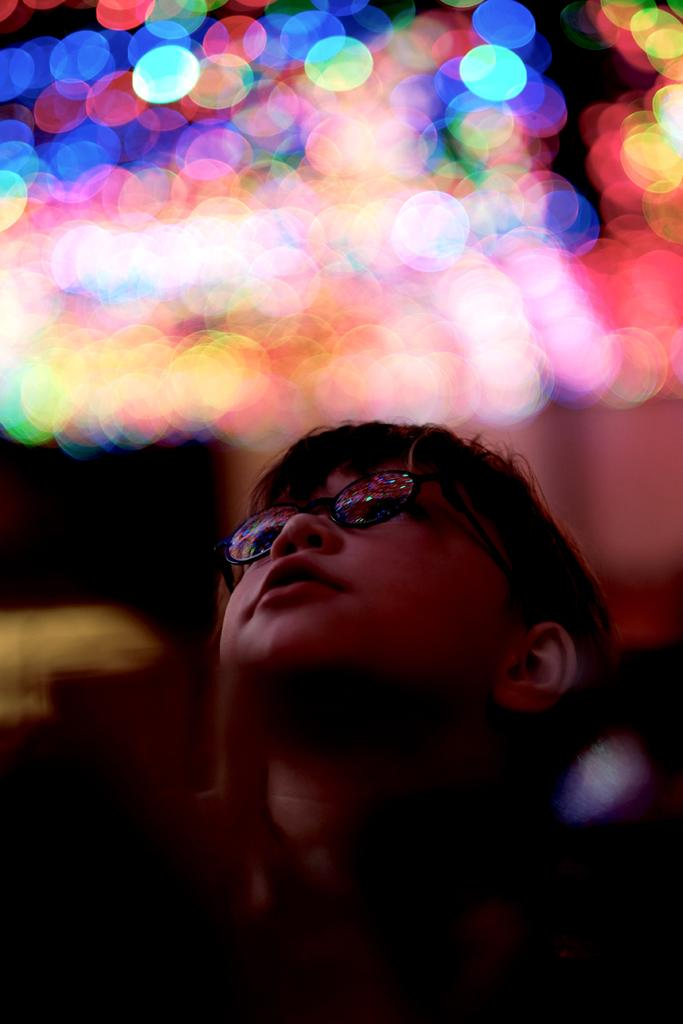What is the main subject of the image? There is a boy standing in the image. Can you describe the background of the image? There are lights visible in the backdrop of the image. How many pigs are present in the image? There are no pigs present in the image. What type of current can be seen flowing through the circle in the image? There is no circle or current present in the image. 